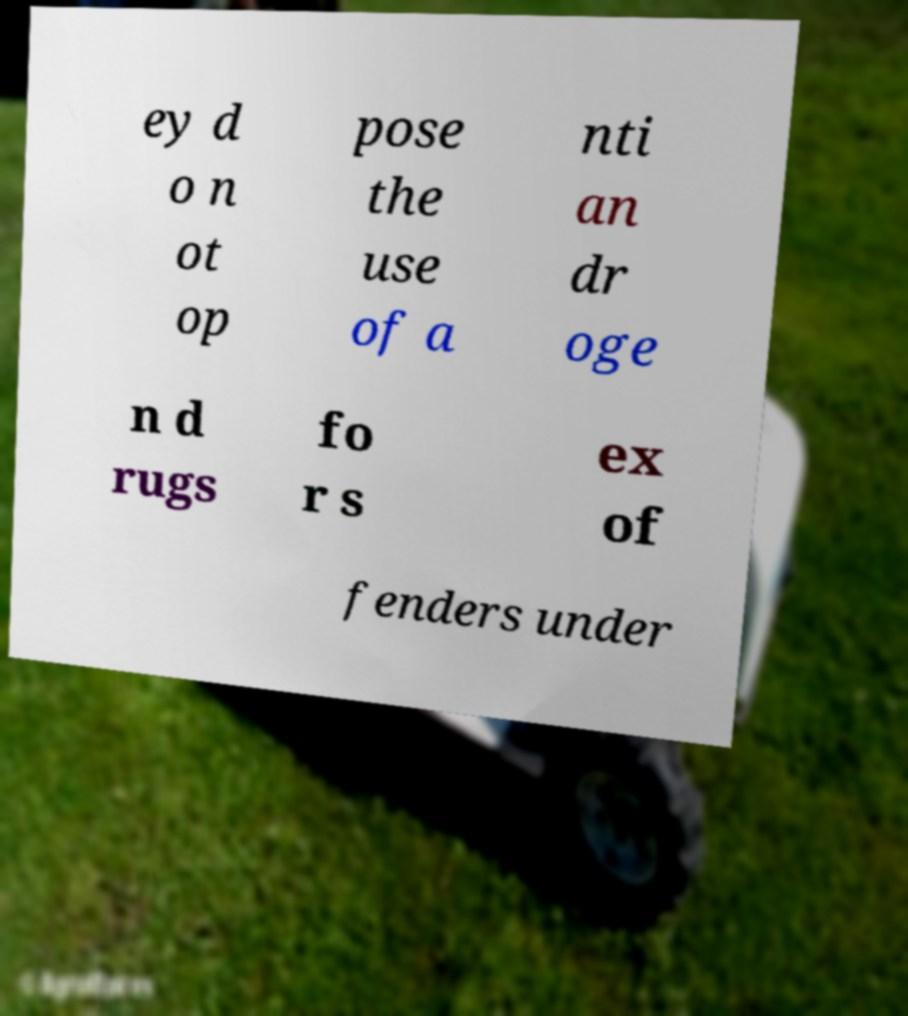Could you assist in decoding the text presented in this image and type it out clearly? ey d o n ot op pose the use of a nti an dr oge n d rugs fo r s ex of fenders under 